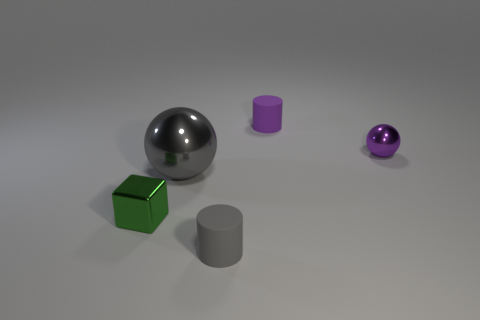Is there any source of light visible in this scene? While there is no direct light source visible in this image, the reflections and shadows on the objects suggest that there's a light source illuminating the scene from the upper left, outside of the frame, giving the objects their visible highlights and casting soft-edged shadows towards the right. 